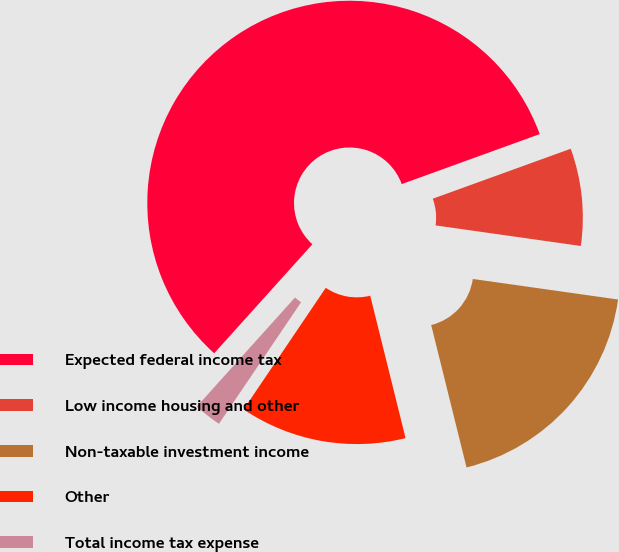Convert chart. <chart><loc_0><loc_0><loc_500><loc_500><pie_chart><fcel>Expected federal income tax<fcel>Low income housing and other<fcel>Non-taxable investment income<fcel>Other<fcel>Total income tax expense<nl><fcel>57.8%<fcel>7.77%<fcel>18.89%<fcel>13.33%<fcel>2.21%<nl></chart> 